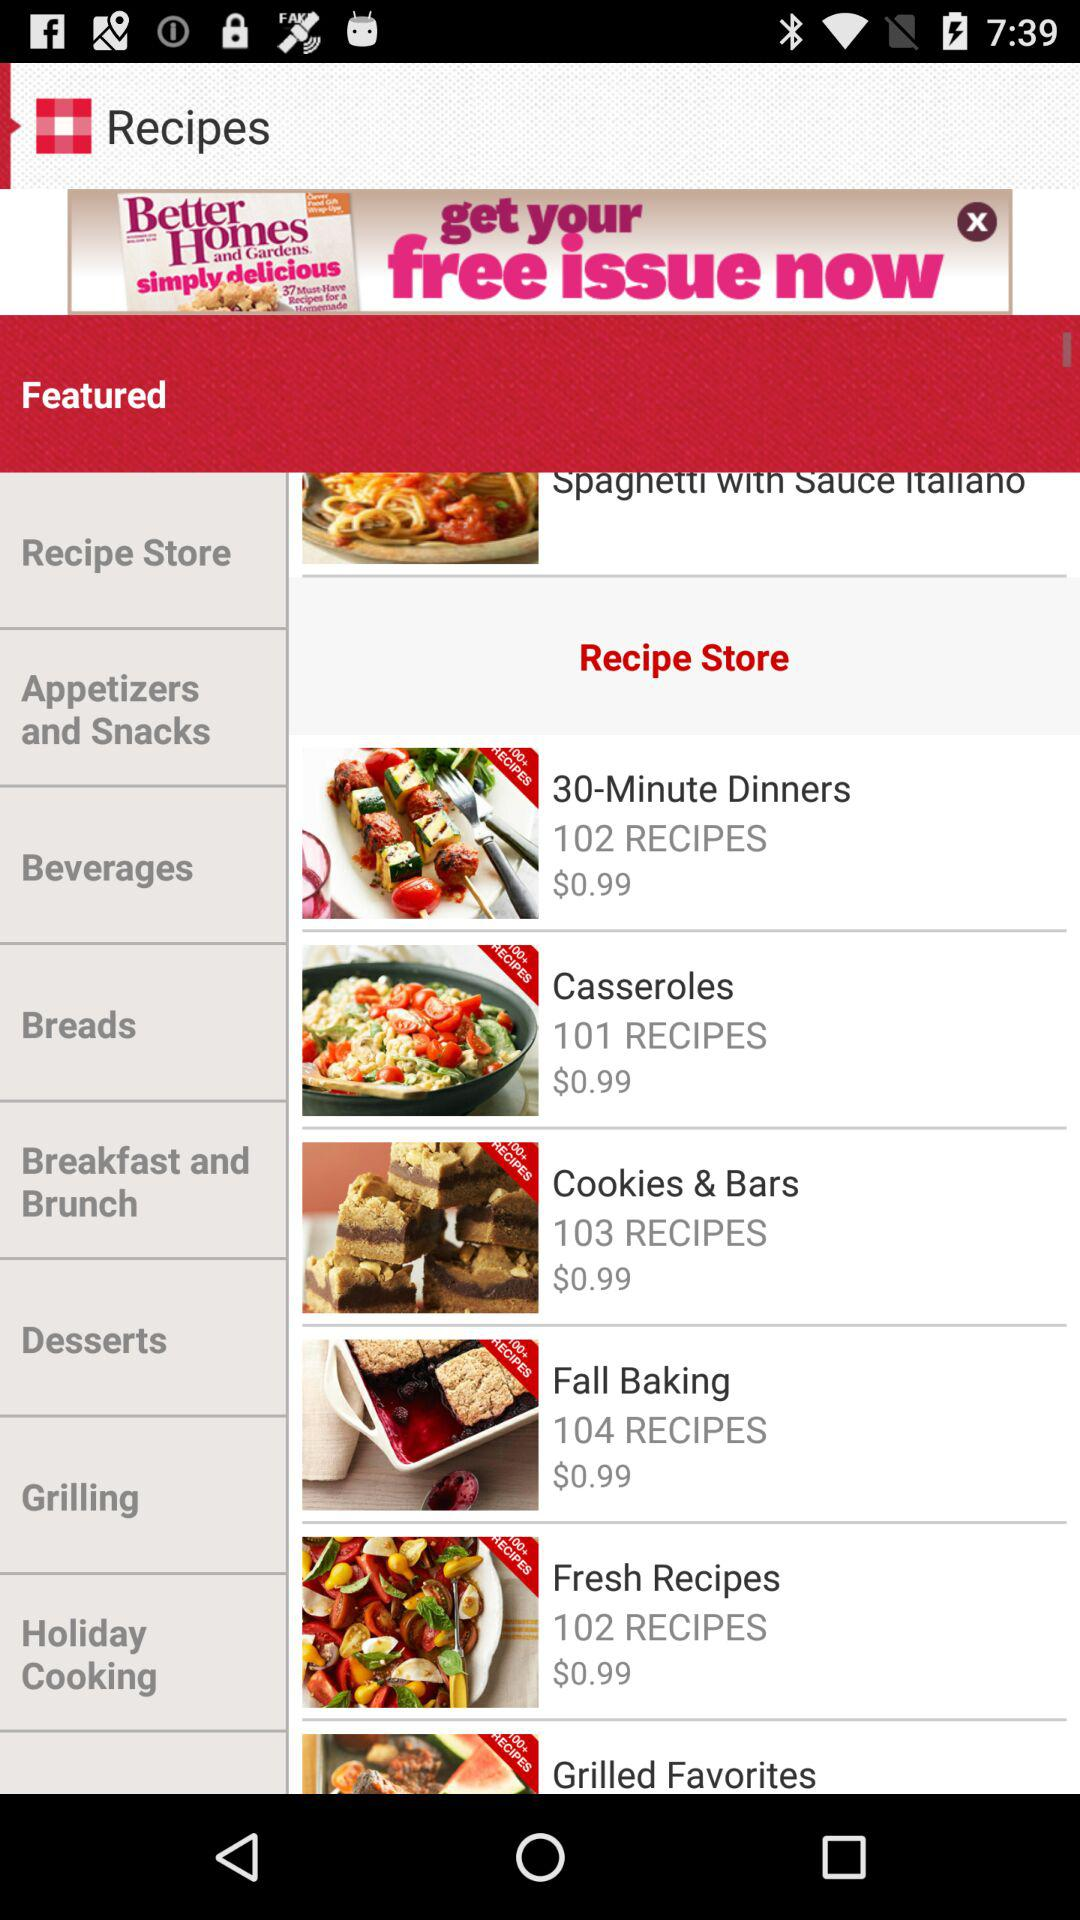How many recipes are available in "Fall Baking"? There are 104 recipes available in "Fall Baking". 